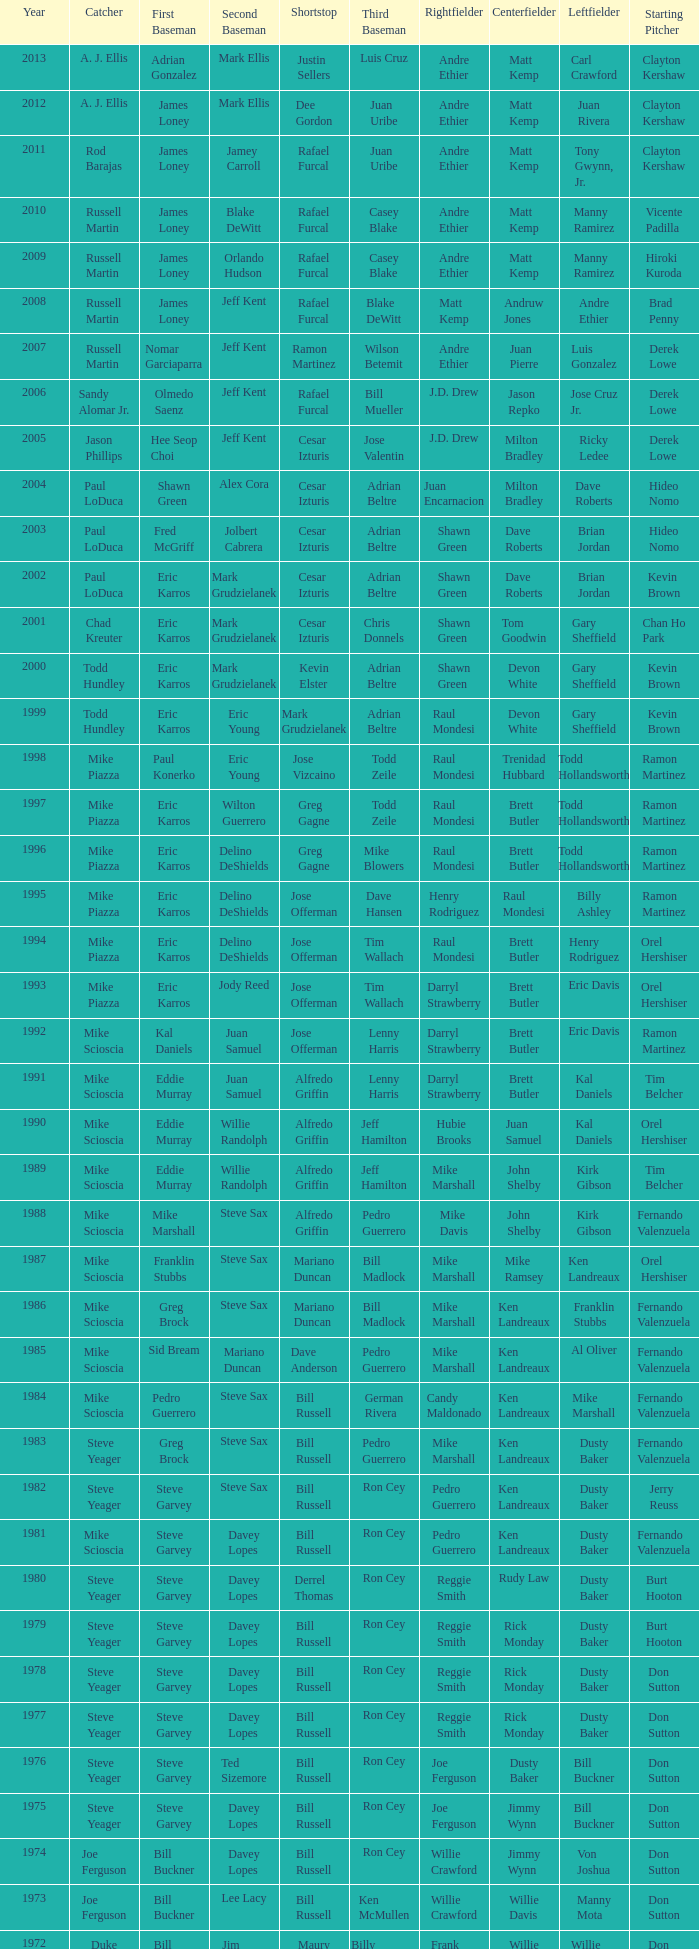Who was the ss during paul konerko's tenure as 1st baseman? Jose Vizcaino. 